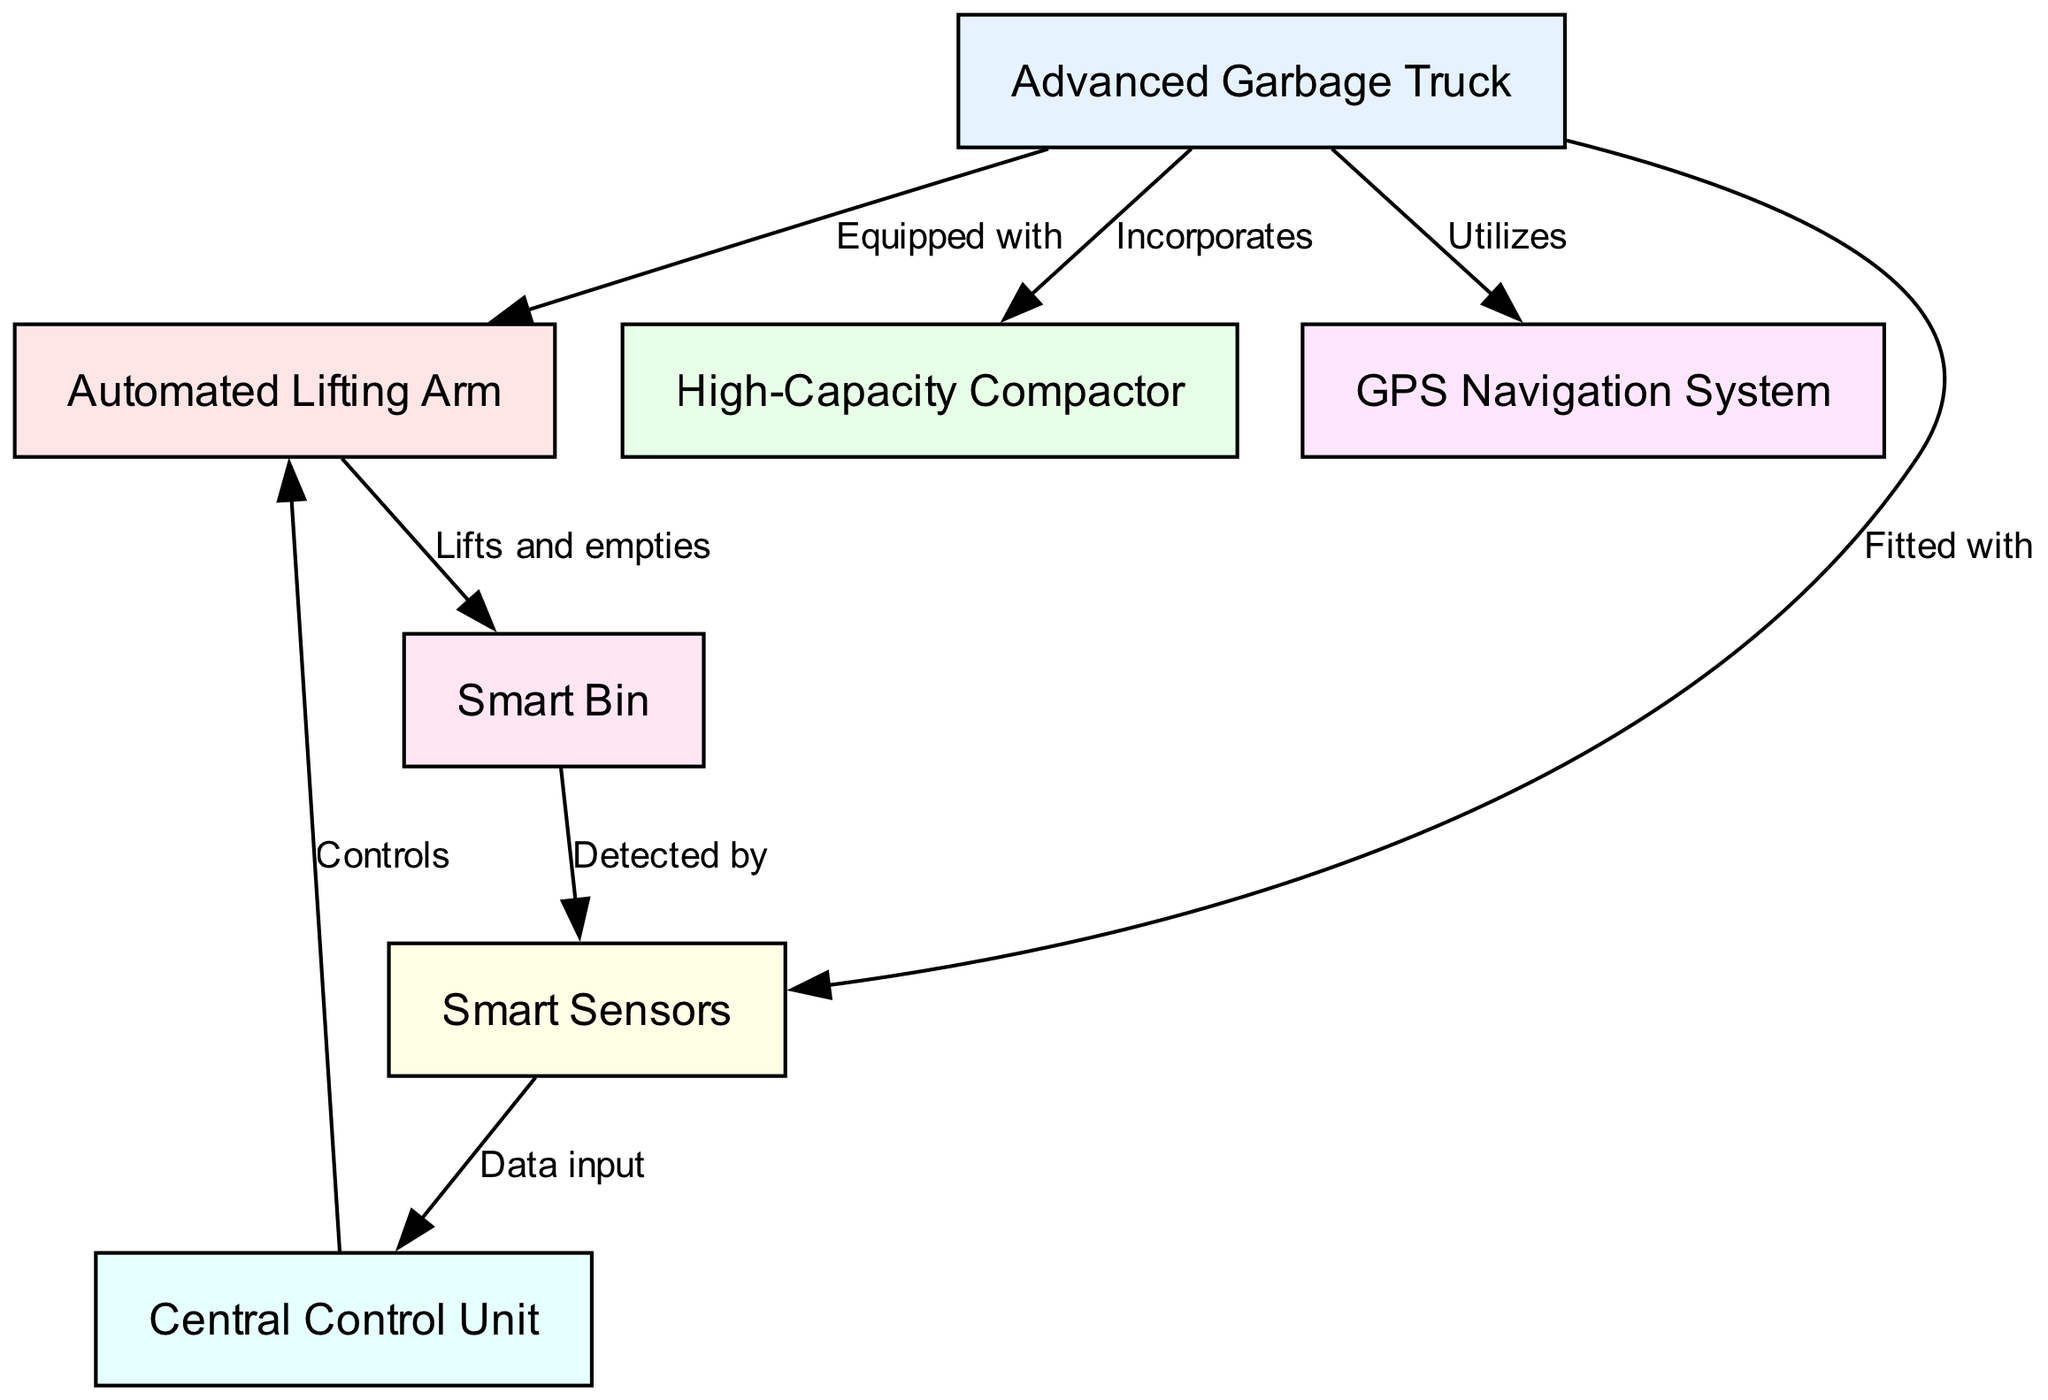What is the total number of nodes in the diagram? The diagram includes nodes representing different components of the garbage truck, which are seven in total: Advanced Garbage Truck, Automated Lifting Arm, High-Capacity Compactor, GPS Navigation System, Smart Sensors, Central Control Unit, and Smart Bin.
Answer: 7 Which component is equipped with the automated lifting arm? The diagram specifies that the Advanced Garbage Truck is equipped with the Automated Lifting Arm, establishing a direct relationship between them.
Answer: Advanced Garbage Truck How many edges are present in the diagram? Counting the connections (edges) between the nodes, there are eight edges that define the relationships among the components of the system.
Answer: 8 What does the central control unit receive data input from? The Smart Sensors provide data input to the Central Control Unit, as indicated by the edge connecting these two nodes in the diagram.
Answer: Smart Sensors Which component does the automated lifting arm lift and empty? According to the diagram, the Automated Lifting Arm is responsible for lifting and emptying the Smart Bin, establishing a direct action relationship between them.
Answer: Smart Bin Which system does the advanced garbage truck utilize for navigation? The GPS Navigation System is utilized by the Advanced Garbage Truck as outlined in the diagram's relationships between nodes.
Answer: GPS Navigation System How many components are directly controlled by the central control unit? The Central Control Unit directly controls the Automated Lifting Arm, indicating a direct relationship in the diagram. Thus, there is one component controlled directly by it.
Answer: 1 What is the role of the smart sensors in the system? The Smart Sensors serve to detect the Smart Bin, providing data that is crucial for the operations managed by the Central Control Unit.
Answer: Detect Which node indicates that the advanced garbage truck incorporates a high-capacity compactor? The edge connecting the Advanced Garbage Truck to the High-Capacity Compactor denotes that the truck incorporates this component, establishing its relationship.
Answer: High-Capacity Compactor 